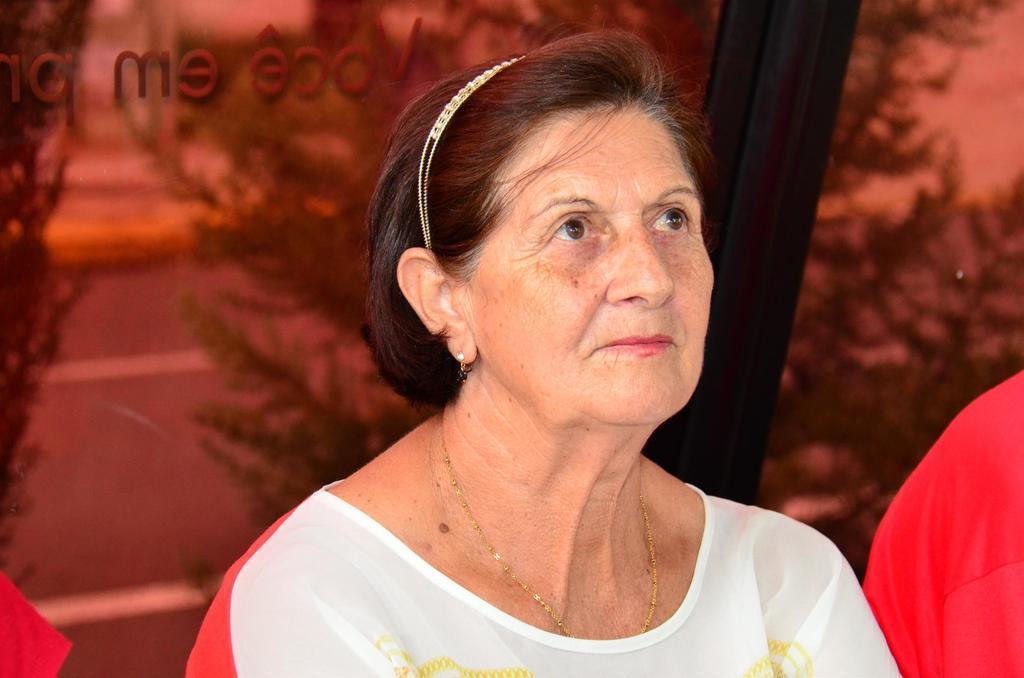Please provide a concise description of this image. In the middle of the picture, we see the old woman is wearing a white dress. She is smiling. Behind her, we see a glass window from which we can see trees. Beside her, we see a red color cloth. 